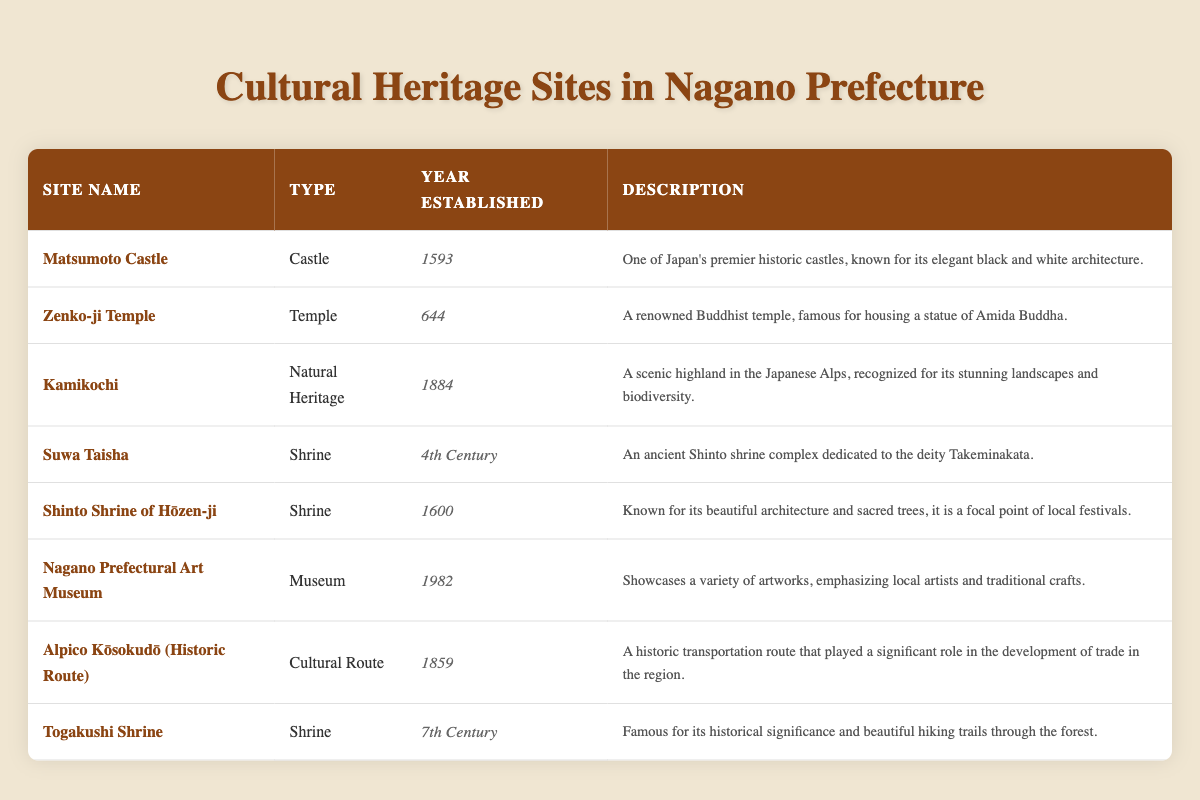What is the year of establishment for Matsumoto Castle? The table lists Matsumoto Castle with its year of establishment as 1593 in the corresponding row under "Year Established."
Answer: 1593 Which site is categorized as a museum? Looking through the table, the only site listed under the type "Museum" is the Nagano Prefectural Art Museum.
Answer: Nagano Prefectural Art Museum How many shrines are mentioned in the table? By counting the rows labeled as "Shrine," there are three sites: Suwa Taisha, Shinto Shrine of Hōzen-ji, and Togakushi Shrine.
Answer: 3 What is the earliest established cultural heritage site in Nagano Prefecture? The table shows that the earliest site is Zenko-ji Temple, established in 644.
Answer: Zenko-ji Temple What type of site is Kamikochi? The table identifies Kamikochi under the "Type" column as "Natural Heritage."
Answer: Natural Heritage Which century was Suwa Taisha established? The table indicates Suwa Taisha was established in the "4th Century."
Answer: 4th Century How many years separate the establishment of Hōzen-ji Shrine and Nagano Prefectural Art Museum? The year of establishment for Hōzen-ji Shrine is 1600 and for Nagano Prefectural Art Museum is 1982. The difference is calculated as 1982 - 1600 = 382 years.
Answer: 382 years Is Togakushi Shrine established before or after the 8th century? Togakushi Shrine is established in the 7th Century, as listed in the table, indicating it was established before the 8th Century.
Answer: Before Among the sites, which has the latest year of establishment? The table clearly shows that the latest year of establishment is for the Nagano Prefectural Art Museum with 1982.
Answer: 1982 What are the types of cultural heritage sites established in the 17th century? By examining the table, the site established in the 17th century is Shinto Shrine of Hōzen-ji, listed as a "Shrine."
Answer: Shinto Shrine of Hōzen-ji How many sites are from the Edo period? Considering the years, Matsumoto Castle (1593), Hōzen-ji Shrine (1600), and Alpico Kōsokudō (1859) fall within the Edo period (1603-1868), totaling three sites.
Answer: 3 